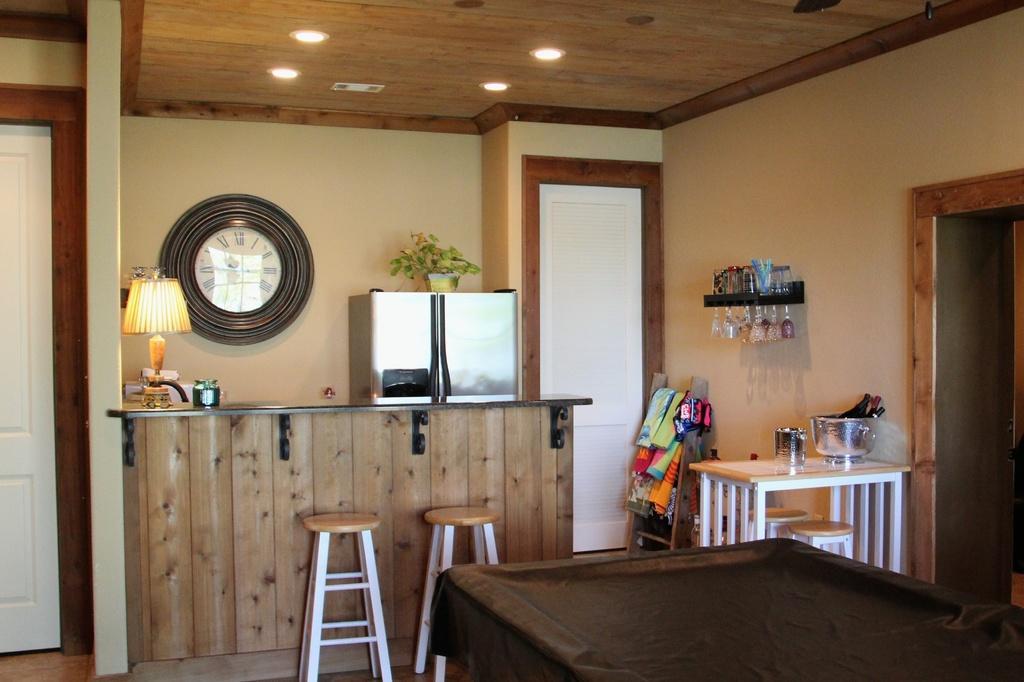Can you describe this image briefly? In the middle of the image we can see clock, refrigerator, potted plant, lamp, countertop, stools and one bottle. Right side of the image, there is a table, stools, towels, stand and glasses. There is a table at the bottom of the image. We can see a door on the left side of the image. 